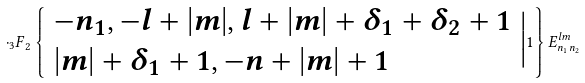<formula> <loc_0><loc_0><loc_500><loc_500>\cdot { _ { 3 } F } _ { 2 } \left \{ \begin{array} { l } { { - n _ { 1 } , - l + | m | , l + | m | + \delta _ { 1 } + \delta _ { 2 } + 1 } } \\ { { | m | + \delta _ { 1 } + 1 , - n + | m | + 1 } } \end{array} \Big | 1 \right \} E _ { n _ { 1 } n _ { 2 } } ^ { l m }</formula> 